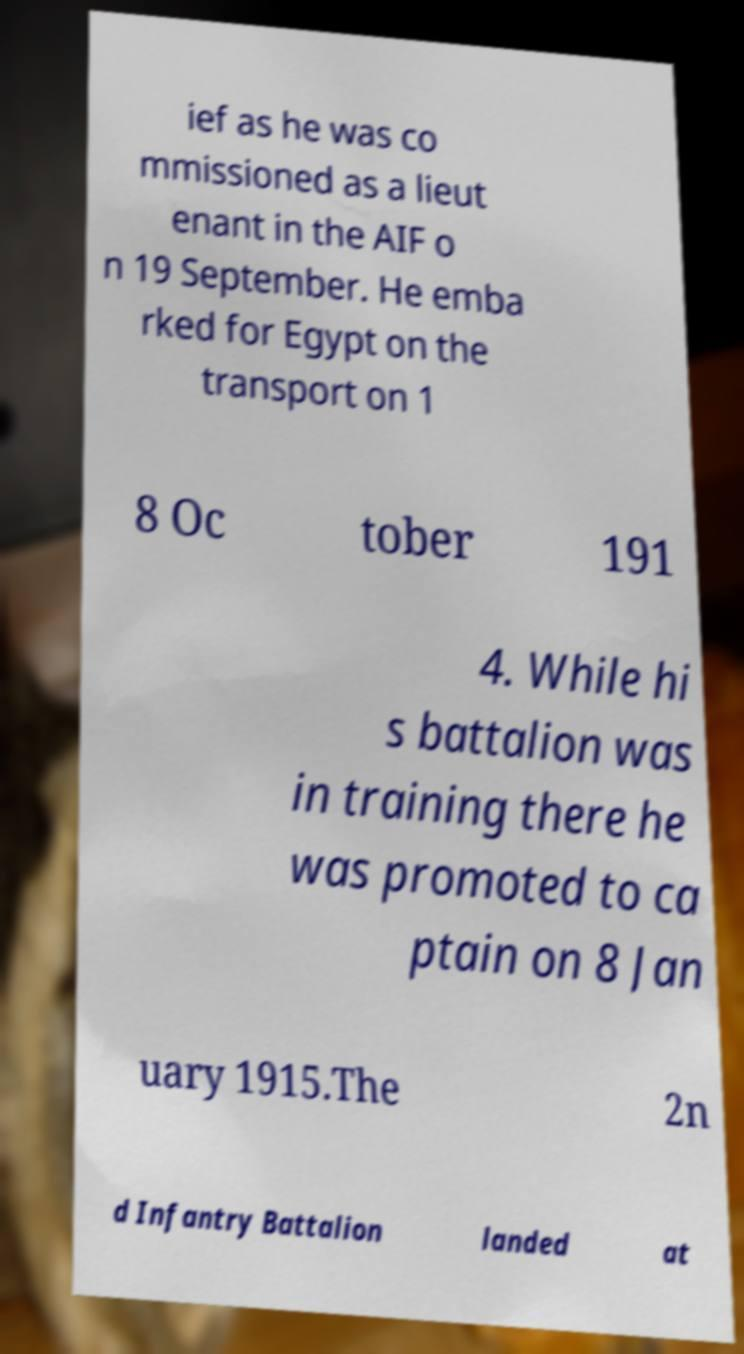Could you extract and type out the text from this image? ief as he was co mmissioned as a lieut enant in the AIF o n 19 September. He emba rked for Egypt on the transport on 1 8 Oc tober 191 4. While hi s battalion was in training there he was promoted to ca ptain on 8 Jan uary 1915.The 2n d Infantry Battalion landed at 